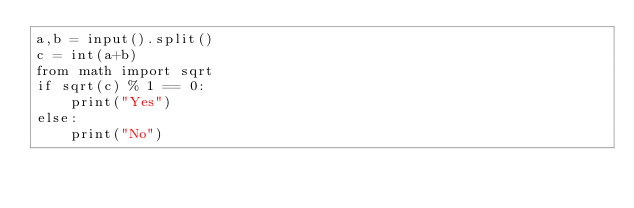<code> <loc_0><loc_0><loc_500><loc_500><_Python_>a,b = input().split()
c = int(a+b)
from math import sqrt
if sqrt(c) % 1 == 0:
    print("Yes")
else:
    print("No")</code> 